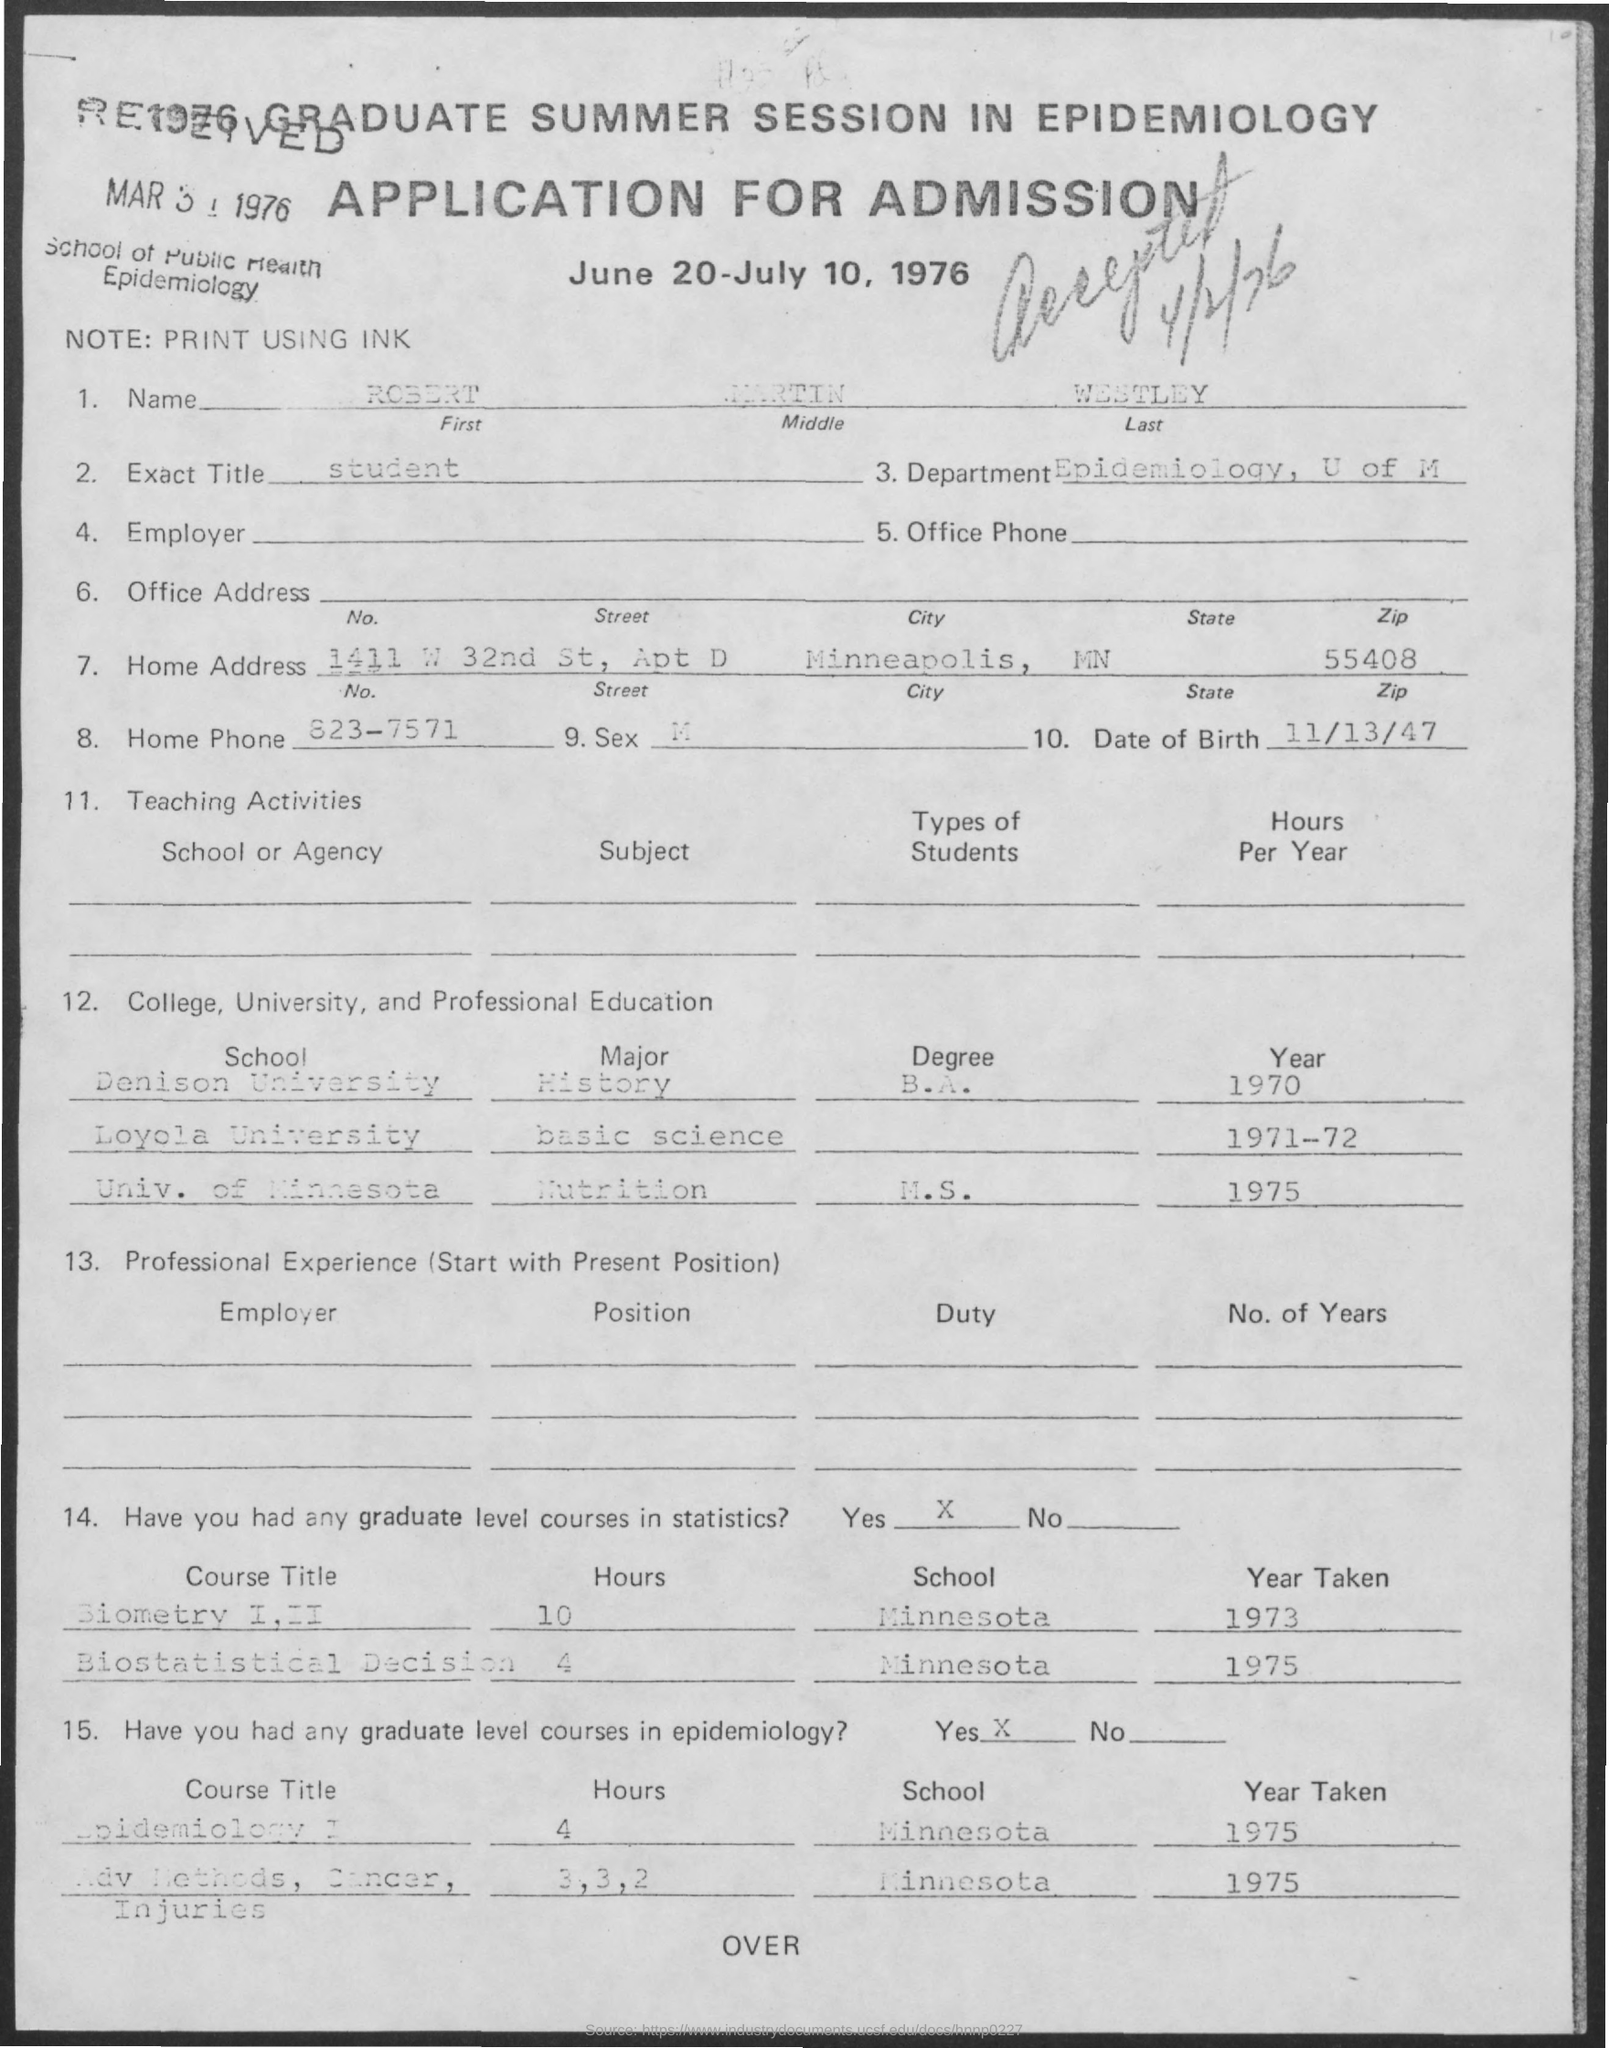Was the applicant involved in any teaching or educational activities? Yes, the applicant was involved in teaching activities, though the document does not specify the subjects taught or the types of students instructed. 